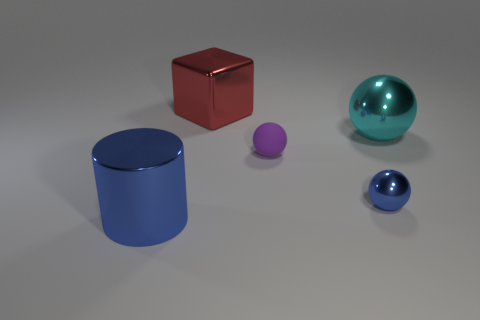There is a cyan metal object that is the same shape as the small matte thing; what is its size?
Provide a succinct answer. Large. What is the shape of the blue metallic object that is to the right of the big metallic cylinder?
Give a very brief answer. Sphere. The shiny thing that is behind the large shiny object to the right of the big block is what color?
Provide a succinct answer. Red. How many objects are either big objects that are right of the large blue metal thing or small purple rubber balls?
Give a very brief answer. 3. Is the size of the blue cylinder the same as the blue metallic thing that is behind the cylinder?
Your answer should be very brief. No. How many large objects are either cylinders or red metallic objects?
Ensure brevity in your answer.  2. What shape is the tiny rubber object?
Give a very brief answer. Sphere. What size is the metal object that is the same color as the big cylinder?
Give a very brief answer. Small. Is there a tiny thing made of the same material as the cube?
Make the answer very short. Yes. Are there more purple matte things than small gray rubber objects?
Give a very brief answer. Yes. 